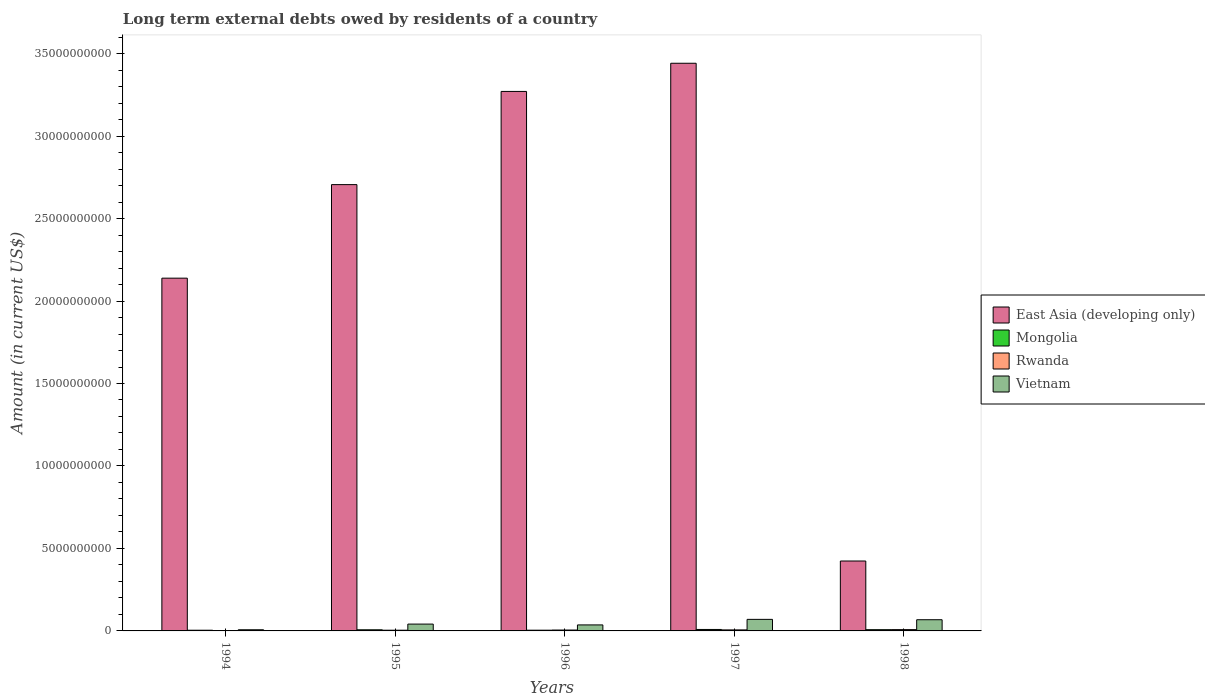Are the number of bars per tick equal to the number of legend labels?
Offer a terse response. Yes. How many bars are there on the 3rd tick from the right?
Your answer should be very brief. 4. In how many cases, is the number of bars for a given year not equal to the number of legend labels?
Offer a very short reply. 0. What is the amount of long-term external debts owed by residents in Vietnam in 1994?
Your response must be concise. 7.06e+07. Across all years, what is the maximum amount of long-term external debts owed by residents in Rwanda?
Your response must be concise. 7.89e+07. Across all years, what is the minimum amount of long-term external debts owed by residents in Vietnam?
Your answer should be compact. 7.06e+07. What is the total amount of long-term external debts owed by residents in East Asia (developing only) in the graph?
Offer a terse response. 1.20e+11. What is the difference between the amount of long-term external debts owed by residents in East Asia (developing only) in 1995 and that in 1997?
Make the answer very short. -7.36e+09. What is the difference between the amount of long-term external debts owed by residents in Mongolia in 1998 and the amount of long-term external debts owed by residents in Rwanda in 1995?
Provide a short and direct response. 3.31e+07. What is the average amount of long-term external debts owed by residents in Mongolia per year?
Offer a terse response. 6.38e+07. In the year 1994, what is the difference between the amount of long-term external debts owed by residents in Vietnam and amount of long-term external debts owed by residents in Rwanda?
Ensure brevity in your answer.  5.03e+07. What is the ratio of the amount of long-term external debts owed by residents in Rwanda in 1994 to that in 1997?
Offer a terse response. 0.33. What is the difference between the highest and the second highest amount of long-term external debts owed by residents in East Asia (developing only)?
Provide a succinct answer. 1.71e+09. What is the difference between the highest and the lowest amount of long-term external debts owed by residents in Vietnam?
Your response must be concise. 6.30e+08. Is it the case that in every year, the sum of the amount of long-term external debts owed by residents in Rwanda and amount of long-term external debts owed by residents in Vietnam is greater than the sum of amount of long-term external debts owed by residents in East Asia (developing only) and amount of long-term external debts owed by residents in Mongolia?
Offer a terse response. No. What does the 4th bar from the left in 1994 represents?
Make the answer very short. Vietnam. What does the 1st bar from the right in 1998 represents?
Keep it short and to the point. Vietnam. Is it the case that in every year, the sum of the amount of long-term external debts owed by residents in East Asia (developing only) and amount of long-term external debts owed by residents in Vietnam is greater than the amount of long-term external debts owed by residents in Rwanda?
Keep it short and to the point. Yes. What is the difference between two consecutive major ticks on the Y-axis?
Your answer should be very brief. 5.00e+09. Where does the legend appear in the graph?
Provide a short and direct response. Center right. What is the title of the graph?
Keep it short and to the point. Long term external debts owed by residents of a country. What is the label or title of the Y-axis?
Keep it short and to the point. Amount (in current US$). What is the Amount (in current US$) in East Asia (developing only) in 1994?
Ensure brevity in your answer.  2.14e+1. What is the Amount (in current US$) in Mongolia in 1994?
Provide a short and direct response. 4.17e+07. What is the Amount (in current US$) in Rwanda in 1994?
Keep it short and to the point. 2.04e+07. What is the Amount (in current US$) of Vietnam in 1994?
Your answer should be compact. 7.06e+07. What is the Amount (in current US$) of East Asia (developing only) in 1995?
Your response must be concise. 2.71e+1. What is the Amount (in current US$) of Mongolia in 1995?
Your response must be concise. 6.84e+07. What is the Amount (in current US$) in Rwanda in 1995?
Give a very brief answer. 4.26e+07. What is the Amount (in current US$) of Vietnam in 1995?
Offer a very short reply. 4.14e+08. What is the Amount (in current US$) of East Asia (developing only) in 1996?
Offer a very short reply. 3.27e+1. What is the Amount (in current US$) of Mongolia in 1996?
Offer a terse response. 4.43e+07. What is the Amount (in current US$) in Rwanda in 1996?
Keep it short and to the point. 5.33e+07. What is the Amount (in current US$) of Vietnam in 1996?
Offer a terse response. 3.64e+08. What is the Amount (in current US$) in East Asia (developing only) in 1997?
Your answer should be compact. 3.44e+1. What is the Amount (in current US$) of Mongolia in 1997?
Your response must be concise. 8.88e+07. What is the Amount (in current US$) in Rwanda in 1997?
Your answer should be compact. 6.18e+07. What is the Amount (in current US$) of Vietnam in 1997?
Make the answer very short. 7.01e+08. What is the Amount (in current US$) of East Asia (developing only) in 1998?
Provide a succinct answer. 4.24e+09. What is the Amount (in current US$) of Mongolia in 1998?
Make the answer very short. 7.57e+07. What is the Amount (in current US$) of Rwanda in 1998?
Keep it short and to the point. 7.89e+07. What is the Amount (in current US$) in Vietnam in 1998?
Offer a very short reply. 6.79e+08. Across all years, what is the maximum Amount (in current US$) in East Asia (developing only)?
Your response must be concise. 3.44e+1. Across all years, what is the maximum Amount (in current US$) of Mongolia?
Keep it short and to the point. 8.88e+07. Across all years, what is the maximum Amount (in current US$) of Rwanda?
Offer a very short reply. 7.89e+07. Across all years, what is the maximum Amount (in current US$) of Vietnam?
Your answer should be compact. 7.01e+08. Across all years, what is the minimum Amount (in current US$) of East Asia (developing only)?
Provide a succinct answer. 4.24e+09. Across all years, what is the minimum Amount (in current US$) of Mongolia?
Ensure brevity in your answer.  4.17e+07. Across all years, what is the minimum Amount (in current US$) in Rwanda?
Your answer should be compact. 2.04e+07. Across all years, what is the minimum Amount (in current US$) in Vietnam?
Give a very brief answer. 7.06e+07. What is the total Amount (in current US$) of East Asia (developing only) in the graph?
Your response must be concise. 1.20e+11. What is the total Amount (in current US$) in Mongolia in the graph?
Your answer should be compact. 3.19e+08. What is the total Amount (in current US$) in Rwanda in the graph?
Offer a very short reply. 2.57e+08. What is the total Amount (in current US$) of Vietnam in the graph?
Make the answer very short. 2.23e+09. What is the difference between the Amount (in current US$) of East Asia (developing only) in 1994 and that in 1995?
Give a very brief answer. -5.67e+09. What is the difference between the Amount (in current US$) of Mongolia in 1994 and that in 1995?
Give a very brief answer. -2.67e+07. What is the difference between the Amount (in current US$) in Rwanda in 1994 and that in 1995?
Offer a terse response. -2.22e+07. What is the difference between the Amount (in current US$) in Vietnam in 1994 and that in 1995?
Your answer should be very brief. -3.43e+08. What is the difference between the Amount (in current US$) of East Asia (developing only) in 1994 and that in 1996?
Your response must be concise. -1.13e+1. What is the difference between the Amount (in current US$) of Mongolia in 1994 and that in 1996?
Your response must be concise. -2.63e+06. What is the difference between the Amount (in current US$) in Rwanda in 1994 and that in 1996?
Your answer should be very brief. -3.29e+07. What is the difference between the Amount (in current US$) of Vietnam in 1994 and that in 1996?
Give a very brief answer. -2.93e+08. What is the difference between the Amount (in current US$) of East Asia (developing only) in 1994 and that in 1997?
Your answer should be very brief. -1.30e+1. What is the difference between the Amount (in current US$) in Mongolia in 1994 and that in 1997?
Your response must be concise. -4.71e+07. What is the difference between the Amount (in current US$) of Rwanda in 1994 and that in 1997?
Your answer should be compact. -4.14e+07. What is the difference between the Amount (in current US$) in Vietnam in 1994 and that in 1997?
Offer a terse response. -6.30e+08. What is the difference between the Amount (in current US$) of East Asia (developing only) in 1994 and that in 1998?
Provide a short and direct response. 1.71e+1. What is the difference between the Amount (in current US$) of Mongolia in 1994 and that in 1998?
Your response must be concise. -3.40e+07. What is the difference between the Amount (in current US$) of Rwanda in 1994 and that in 1998?
Ensure brevity in your answer.  -5.85e+07. What is the difference between the Amount (in current US$) in Vietnam in 1994 and that in 1998?
Make the answer very short. -6.08e+08. What is the difference between the Amount (in current US$) in East Asia (developing only) in 1995 and that in 1996?
Your answer should be very brief. -5.65e+09. What is the difference between the Amount (in current US$) of Mongolia in 1995 and that in 1996?
Your answer should be very brief. 2.41e+07. What is the difference between the Amount (in current US$) of Rwanda in 1995 and that in 1996?
Provide a succinct answer. -1.07e+07. What is the difference between the Amount (in current US$) in Vietnam in 1995 and that in 1996?
Your response must be concise. 5.02e+07. What is the difference between the Amount (in current US$) of East Asia (developing only) in 1995 and that in 1997?
Offer a terse response. -7.36e+09. What is the difference between the Amount (in current US$) of Mongolia in 1995 and that in 1997?
Offer a very short reply. -2.04e+07. What is the difference between the Amount (in current US$) in Rwanda in 1995 and that in 1997?
Ensure brevity in your answer.  -1.92e+07. What is the difference between the Amount (in current US$) of Vietnam in 1995 and that in 1997?
Keep it short and to the point. -2.86e+08. What is the difference between the Amount (in current US$) of East Asia (developing only) in 1995 and that in 1998?
Provide a succinct answer. 2.28e+1. What is the difference between the Amount (in current US$) in Mongolia in 1995 and that in 1998?
Your response must be concise. -7.26e+06. What is the difference between the Amount (in current US$) in Rwanda in 1995 and that in 1998?
Offer a terse response. -3.63e+07. What is the difference between the Amount (in current US$) in Vietnam in 1995 and that in 1998?
Keep it short and to the point. -2.65e+08. What is the difference between the Amount (in current US$) in East Asia (developing only) in 1996 and that in 1997?
Ensure brevity in your answer.  -1.71e+09. What is the difference between the Amount (in current US$) of Mongolia in 1996 and that in 1997?
Your response must be concise. -4.45e+07. What is the difference between the Amount (in current US$) in Rwanda in 1996 and that in 1997?
Provide a succinct answer. -8.49e+06. What is the difference between the Amount (in current US$) in Vietnam in 1996 and that in 1997?
Give a very brief answer. -3.37e+08. What is the difference between the Amount (in current US$) in East Asia (developing only) in 1996 and that in 1998?
Make the answer very short. 2.85e+1. What is the difference between the Amount (in current US$) in Mongolia in 1996 and that in 1998?
Keep it short and to the point. -3.13e+07. What is the difference between the Amount (in current US$) in Rwanda in 1996 and that in 1998?
Provide a short and direct response. -2.56e+07. What is the difference between the Amount (in current US$) in Vietnam in 1996 and that in 1998?
Give a very brief answer. -3.15e+08. What is the difference between the Amount (in current US$) of East Asia (developing only) in 1997 and that in 1998?
Provide a succinct answer. 3.02e+1. What is the difference between the Amount (in current US$) in Mongolia in 1997 and that in 1998?
Provide a short and direct response. 1.32e+07. What is the difference between the Amount (in current US$) in Rwanda in 1997 and that in 1998?
Ensure brevity in your answer.  -1.71e+07. What is the difference between the Amount (in current US$) of Vietnam in 1997 and that in 1998?
Offer a terse response. 2.19e+07. What is the difference between the Amount (in current US$) in East Asia (developing only) in 1994 and the Amount (in current US$) in Mongolia in 1995?
Ensure brevity in your answer.  2.13e+1. What is the difference between the Amount (in current US$) of East Asia (developing only) in 1994 and the Amount (in current US$) of Rwanda in 1995?
Your answer should be compact. 2.13e+1. What is the difference between the Amount (in current US$) of East Asia (developing only) in 1994 and the Amount (in current US$) of Vietnam in 1995?
Keep it short and to the point. 2.10e+1. What is the difference between the Amount (in current US$) in Mongolia in 1994 and the Amount (in current US$) in Rwanda in 1995?
Your response must be concise. -8.97e+05. What is the difference between the Amount (in current US$) of Mongolia in 1994 and the Amount (in current US$) of Vietnam in 1995?
Provide a short and direct response. -3.72e+08. What is the difference between the Amount (in current US$) of Rwanda in 1994 and the Amount (in current US$) of Vietnam in 1995?
Keep it short and to the point. -3.94e+08. What is the difference between the Amount (in current US$) of East Asia (developing only) in 1994 and the Amount (in current US$) of Mongolia in 1996?
Make the answer very short. 2.13e+1. What is the difference between the Amount (in current US$) in East Asia (developing only) in 1994 and the Amount (in current US$) in Rwanda in 1996?
Offer a terse response. 2.13e+1. What is the difference between the Amount (in current US$) in East Asia (developing only) in 1994 and the Amount (in current US$) in Vietnam in 1996?
Your answer should be compact. 2.10e+1. What is the difference between the Amount (in current US$) of Mongolia in 1994 and the Amount (in current US$) of Rwanda in 1996?
Your response must be concise. -1.16e+07. What is the difference between the Amount (in current US$) of Mongolia in 1994 and the Amount (in current US$) of Vietnam in 1996?
Your answer should be very brief. -3.22e+08. What is the difference between the Amount (in current US$) of Rwanda in 1994 and the Amount (in current US$) of Vietnam in 1996?
Offer a very short reply. -3.44e+08. What is the difference between the Amount (in current US$) in East Asia (developing only) in 1994 and the Amount (in current US$) in Mongolia in 1997?
Your answer should be compact. 2.13e+1. What is the difference between the Amount (in current US$) in East Asia (developing only) in 1994 and the Amount (in current US$) in Rwanda in 1997?
Provide a succinct answer. 2.13e+1. What is the difference between the Amount (in current US$) of East Asia (developing only) in 1994 and the Amount (in current US$) of Vietnam in 1997?
Your answer should be compact. 2.07e+1. What is the difference between the Amount (in current US$) in Mongolia in 1994 and the Amount (in current US$) in Rwanda in 1997?
Make the answer very short. -2.01e+07. What is the difference between the Amount (in current US$) in Mongolia in 1994 and the Amount (in current US$) in Vietnam in 1997?
Offer a very short reply. -6.59e+08. What is the difference between the Amount (in current US$) in Rwanda in 1994 and the Amount (in current US$) in Vietnam in 1997?
Provide a succinct answer. -6.80e+08. What is the difference between the Amount (in current US$) in East Asia (developing only) in 1994 and the Amount (in current US$) in Mongolia in 1998?
Offer a terse response. 2.13e+1. What is the difference between the Amount (in current US$) in East Asia (developing only) in 1994 and the Amount (in current US$) in Rwanda in 1998?
Provide a short and direct response. 2.13e+1. What is the difference between the Amount (in current US$) of East Asia (developing only) in 1994 and the Amount (in current US$) of Vietnam in 1998?
Offer a terse response. 2.07e+1. What is the difference between the Amount (in current US$) in Mongolia in 1994 and the Amount (in current US$) in Rwanda in 1998?
Your response must be concise. -3.72e+07. What is the difference between the Amount (in current US$) in Mongolia in 1994 and the Amount (in current US$) in Vietnam in 1998?
Offer a very short reply. -6.37e+08. What is the difference between the Amount (in current US$) in Rwanda in 1994 and the Amount (in current US$) in Vietnam in 1998?
Make the answer very short. -6.58e+08. What is the difference between the Amount (in current US$) in East Asia (developing only) in 1995 and the Amount (in current US$) in Mongolia in 1996?
Offer a very short reply. 2.70e+1. What is the difference between the Amount (in current US$) in East Asia (developing only) in 1995 and the Amount (in current US$) in Rwanda in 1996?
Keep it short and to the point. 2.70e+1. What is the difference between the Amount (in current US$) of East Asia (developing only) in 1995 and the Amount (in current US$) of Vietnam in 1996?
Make the answer very short. 2.67e+1. What is the difference between the Amount (in current US$) of Mongolia in 1995 and the Amount (in current US$) of Rwanda in 1996?
Ensure brevity in your answer.  1.51e+07. What is the difference between the Amount (in current US$) in Mongolia in 1995 and the Amount (in current US$) in Vietnam in 1996?
Your answer should be very brief. -2.96e+08. What is the difference between the Amount (in current US$) of Rwanda in 1995 and the Amount (in current US$) of Vietnam in 1996?
Your answer should be very brief. -3.21e+08. What is the difference between the Amount (in current US$) of East Asia (developing only) in 1995 and the Amount (in current US$) of Mongolia in 1997?
Offer a terse response. 2.70e+1. What is the difference between the Amount (in current US$) of East Asia (developing only) in 1995 and the Amount (in current US$) of Rwanda in 1997?
Make the answer very short. 2.70e+1. What is the difference between the Amount (in current US$) in East Asia (developing only) in 1995 and the Amount (in current US$) in Vietnam in 1997?
Offer a terse response. 2.64e+1. What is the difference between the Amount (in current US$) in Mongolia in 1995 and the Amount (in current US$) in Rwanda in 1997?
Ensure brevity in your answer.  6.60e+06. What is the difference between the Amount (in current US$) in Mongolia in 1995 and the Amount (in current US$) in Vietnam in 1997?
Ensure brevity in your answer.  -6.32e+08. What is the difference between the Amount (in current US$) of Rwanda in 1995 and the Amount (in current US$) of Vietnam in 1997?
Make the answer very short. -6.58e+08. What is the difference between the Amount (in current US$) in East Asia (developing only) in 1995 and the Amount (in current US$) in Mongolia in 1998?
Offer a terse response. 2.70e+1. What is the difference between the Amount (in current US$) in East Asia (developing only) in 1995 and the Amount (in current US$) in Rwanda in 1998?
Ensure brevity in your answer.  2.70e+1. What is the difference between the Amount (in current US$) of East Asia (developing only) in 1995 and the Amount (in current US$) of Vietnam in 1998?
Offer a terse response. 2.64e+1. What is the difference between the Amount (in current US$) in Mongolia in 1995 and the Amount (in current US$) in Rwanda in 1998?
Give a very brief answer. -1.05e+07. What is the difference between the Amount (in current US$) of Mongolia in 1995 and the Amount (in current US$) of Vietnam in 1998?
Provide a succinct answer. -6.10e+08. What is the difference between the Amount (in current US$) of Rwanda in 1995 and the Amount (in current US$) of Vietnam in 1998?
Your response must be concise. -6.36e+08. What is the difference between the Amount (in current US$) in East Asia (developing only) in 1996 and the Amount (in current US$) in Mongolia in 1997?
Offer a terse response. 3.26e+1. What is the difference between the Amount (in current US$) of East Asia (developing only) in 1996 and the Amount (in current US$) of Rwanda in 1997?
Provide a short and direct response. 3.26e+1. What is the difference between the Amount (in current US$) in East Asia (developing only) in 1996 and the Amount (in current US$) in Vietnam in 1997?
Provide a succinct answer. 3.20e+1. What is the difference between the Amount (in current US$) of Mongolia in 1996 and the Amount (in current US$) of Rwanda in 1997?
Offer a terse response. -1.75e+07. What is the difference between the Amount (in current US$) of Mongolia in 1996 and the Amount (in current US$) of Vietnam in 1997?
Your answer should be very brief. -6.56e+08. What is the difference between the Amount (in current US$) in Rwanda in 1996 and the Amount (in current US$) in Vietnam in 1997?
Your answer should be very brief. -6.47e+08. What is the difference between the Amount (in current US$) of East Asia (developing only) in 1996 and the Amount (in current US$) of Mongolia in 1998?
Offer a terse response. 3.26e+1. What is the difference between the Amount (in current US$) in East Asia (developing only) in 1996 and the Amount (in current US$) in Rwanda in 1998?
Make the answer very short. 3.26e+1. What is the difference between the Amount (in current US$) of East Asia (developing only) in 1996 and the Amount (in current US$) of Vietnam in 1998?
Give a very brief answer. 3.20e+1. What is the difference between the Amount (in current US$) of Mongolia in 1996 and the Amount (in current US$) of Rwanda in 1998?
Ensure brevity in your answer.  -3.45e+07. What is the difference between the Amount (in current US$) of Mongolia in 1996 and the Amount (in current US$) of Vietnam in 1998?
Your response must be concise. -6.34e+08. What is the difference between the Amount (in current US$) in Rwanda in 1996 and the Amount (in current US$) in Vietnam in 1998?
Offer a very short reply. -6.25e+08. What is the difference between the Amount (in current US$) of East Asia (developing only) in 1997 and the Amount (in current US$) of Mongolia in 1998?
Ensure brevity in your answer.  3.43e+1. What is the difference between the Amount (in current US$) in East Asia (developing only) in 1997 and the Amount (in current US$) in Rwanda in 1998?
Offer a very short reply. 3.43e+1. What is the difference between the Amount (in current US$) of East Asia (developing only) in 1997 and the Amount (in current US$) of Vietnam in 1998?
Your answer should be compact. 3.37e+1. What is the difference between the Amount (in current US$) of Mongolia in 1997 and the Amount (in current US$) of Rwanda in 1998?
Offer a terse response. 9.96e+06. What is the difference between the Amount (in current US$) of Mongolia in 1997 and the Amount (in current US$) of Vietnam in 1998?
Give a very brief answer. -5.90e+08. What is the difference between the Amount (in current US$) in Rwanda in 1997 and the Amount (in current US$) in Vietnam in 1998?
Provide a short and direct response. -6.17e+08. What is the average Amount (in current US$) of East Asia (developing only) per year?
Your answer should be very brief. 2.40e+1. What is the average Amount (in current US$) of Mongolia per year?
Offer a very short reply. 6.38e+07. What is the average Amount (in current US$) in Rwanda per year?
Your answer should be compact. 5.14e+07. What is the average Amount (in current US$) in Vietnam per year?
Keep it short and to the point. 4.46e+08. In the year 1994, what is the difference between the Amount (in current US$) in East Asia (developing only) and Amount (in current US$) in Mongolia?
Offer a terse response. 2.13e+1. In the year 1994, what is the difference between the Amount (in current US$) in East Asia (developing only) and Amount (in current US$) in Rwanda?
Offer a terse response. 2.14e+1. In the year 1994, what is the difference between the Amount (in current US$) of East Asia (developing only) and Amount (in current US$) of Vietnam?
Offer a very short reply. 2.13e+1. In the year 1994, what is the difference between the Amount (in current US$) of Mongolia and Amount (in current US$) of Rwanda?
Your response must be concise. 2.13e+07. In the year 1994, what is the difference between the Amount (in current US$) in Mongolia and Amount (in current US$) in Vietnam?
Provide a short and direct response. -2.89e+07. In the year 1994, what is the difference between the Amount (in current US$) of Rwanda and Amount (in current US$) of Vietnam?
Offer a terse response. -5.03e+07. In the year 1995, what is the difference between the Amount (in current US$) in East Asia (developing only) and Amount (in current US$) in Mongolia?
Make the answer very short. 2.70e+1. In the year 1995, what is the difference between the Amount (in current US$) of East Asia (developing only) and Amount (in current US$) of Rwanda?
Your response must be concise. 2.70e+1. In the year 1995, what is the difference between the Amount (in current US$) of East Asia (developing only) and Amount (in current US$) of Vietnam?
Offer a terse response. 2.66e+1. In the year 1995, what is the difference between the Amount (in current US$) of Mongolia and Amount (in current US$) of Rwanda?
Provide a short and direct response. 2.58e+07. In the year 1995, what is the difference between the Amount (in current US$) of Mongolia and Amount (in current US$) of Vietnam?
Give a very brief answer. -3.46e+08. In the year 1995, what is the difference between the Amount (in current US$) in Rwanda and Amount (in current US$) in Vietnam?
Your response must be concise. -3.72e+08. In the year 1996, what is the difference between the Amount (in current US$) in East Asia (developing only) and Amount (in current US$) in Mongolia?
Your answer should be very brief. 3.27e+1. In the year 1996, what is the difference between the Amount (in current US$) of East Asia (developing only) and Amount (in current US$) of Rwanda?
Your response must be concise. 3.27e+1. In the year 1996, what is the difference between the Amount (in current US$) of East Asia (developing only) and Amount (in current US$) of Vietnam?
Make the answer very short. 3.23e+1. In the year 1996, what is the difference between the Amount (in current US$) of Mongolia and Amount (in current US$) of Rwanda?
Keep it short and to the point. -8.96e+06. In the year 1996, what is the difference between the Amount (in current US$) of Mongolia and Amount (in current US$) of Vietnam?
Offer a terse response. -3.20e+08. In the year 1996, what is the difference between the Amount (in current US$) in Rwanda and Amount (in current US$) in Vietnam?
Your answer should be compact. -3.11e+08. In the year 1997, what is the difference between the Amount (in current US$) of East Asia (developing only) and Amount (in current US$) of Mongolia?
Ensure brevity in your answer.  3.43e+1. In the year 1997, what is the difference between the Amount (in current US$) of East Asia (developing only) and Amount (in current US$) of Rwanda?
Offer a very short reply. 3.44e+1. In the year 1997, what is the difference between the Amount (in current US$) of East Asia (developing only) and Amount (in current US$) of Vietnam?
Your answer should be compact. 3.37e+1. In the year 1997, what is the difference between the Amount (in current US$) in Mongolia and Amount (in current US$) in Rwanda?
Ensure brevity in your answer.  2.70e+07. In the year 1997, what is the difference between the Amount (in current US$) of Mongolia and Amount (in current US$) of Vietnam?
Offer a terse response. -6.12e+08. In the year 1997, what is the difference between the Amount (in current US$) of Rwanda and Amount (in current US$) of Vietnam?
Keep it short and to the point. -6.39e+08. In the year 1998, what is the difference between the Amount (in current US$) in East Asia (developing only) and Amount (in current US$) in Mongolia?
Give a very brief answer. 4.16e+09. In the year 1998, what is the difference between the Amount (in current US$) in East Asia (developing only) and Amount (in current US$) in Rwanda?
Ensure brevity in your answer.  4.16e+09. In the year 1998, what is the difference between the Amount (in current US$) of East Asia (developing only) and Amount (in current US$) of Vietnam?
Offer a terse response. 3.56e+09. In the year 1998, what is the difference between the Amount (in current US$) in Mongolia and Amount (in current US$) in Rwanda?
Keep it short and to the point. -3.20e+06. In the year 1998, what is the difference between the Amount (in current US$) in Mongolia and Amount (in current US$) in Vietnam?
Provide a short and direct response. -6.03e+08. In the year 1998, what is the difference between the Amount (in current US$) in Rwanda and Amount (in current US$) in Vietnam?
Give a very brief answer. -6.00e+08. What is the ratio of the Amount (in current US$) of East Asia (developing only) in 1994 to that in 1995?
Your answer should be compact. 0.79. What is the ratio of the Amount (in current US$) in Mongolia in 1994 to that in 1995?
Offer a terse response. 0.61. What is the ratio of the Amount (in current US$) of Rwanda in 1994 to that in 1995?
Offer a terse response. 0.48. What is the ratio of the Amount (in current US$) in Vietnam in 1994 to that in 1995?
Provide a short and direct response. 0.17. What is the ratio of the Amount (in current US$) of East Asia (developing only) in 1994 to that in 1996?
Provide a short and direct response. 0.65. What is the ratio of the Amount (in current US$) of Mongolia in 1994 to that in 1996?
Keep it short and to the point. 0.94. What is the ratio of the Amount (in current US$) in Rwanda in 1994 to that in 1996?
Provide a short and direct response. 0.38. What is the ratio of the Amount (in current US$) in Vietnam in 1994 to that in 1996?
Make the answer very short. 0.19. What is the ratio of the Amount (in current US$) of East Asia (developing only) in 1994 to that in 1997?
Offer a very short reply. 0.62. What is the ratio of the Amount (in current US$) of Mongolia in 1994 to that in 1997?
Provide a short and direct response. 0.47. What is the ratio of the Amount (in current US$) of Rwanda in 1994 to that in 1997?
Your answer should be very brief. 0.33. What is the ratio of the Amount (in current US$) of Vietnam in 1994 to that in 1997?
Offer a terse response. 0.1. What is the ratio of the Amount (in current US$) in East Asia (developing only) in 1994 to that in 1998?
Provide a succinct answer. 5.05. What is the ratio of the Amount (in current US$) of Mongolia in 1994 to that in 1998?
Make the answer very short. 0.55. What is the ratio of the Amount (in current US$) in Rwanda in 1994 to that in 1998?
Offer a terse response. 0.26. What is the ratio of the Amount (in current US$) in Vietnam in 1994 to that in 1998?
Provide a succinct answer. 0.1. What is the ratio of the Amount (in current US$) in East Asia (developing only) in 1995 to that in 1996?
Offer a terse response. 0.83. What is the ratio of the Amount (in current US$) of Mongolia in 1995 to that in 1996?
Keep it short and to the point. 1.54. What is the ratio of the Amount (in current US$) in Rwanda in 1995 to that in 1996?
Your answer should be very brief. 0.8. What is the ratio of the Amount (in current US$) in Vietnam in 1995 to that in 1996?
Provide a short and direct response. 1.14. What is the ratio of the Amount (in current US$) of East Asia (developing only) in 1995 to that in 1997?
Offer a very short reply. 0.79. What is the ratio of the Amount (in current US$) of Mongolia in 1995 to that in 1997?
Provide a short and direct response. 0.77. What is the ratio of the Amount (in current US$) of Rwanda in 1995 to that in 1997?
Your answer should be compact. 0.69. What is the ratio of the Amount (in current US$) in Vietnam in 1995 to that in 1997?
Your answer should be very brief. 0.59. What is the ratio of the Amount (in current US$) of East Asia (developing only) in 1995 to that in 1998?
Offer a very short reply. 6.38. What is the ratio of the Amount (in current US$) of Mongolia in 1995 to that in 1998?
Give a very brief answer. 0.9. What is the ratio of the Amount (in current US$) of Rwanda in 1995 to that in 1998?
Your answer should be very brief. 0.54. What is the ratio of the Amount (in current US$) of Vietnam in 1995 to that in 1998?
Keep it short and to the point. 0.61. What is the ratio of the Amount (in current US$) in East Asia (developing only) in 1996 to that in 1997?
Give a very brief answer. 0.95. What is the ratio of the Amount (in current US$) in Mongolia in 1996 to that in 1997?
Give a very brief answer. 0.5. What is the ratio of the Amount (in current US$) of Rwanda in 1996 to that in 1997?
Ensure brevity in your answer.  0.86. What is the ratio of the Amount (in current US$) of Vietnam in 1996 to that in 1997?
Your answer should be compact. 0.52. What is the ratio of the Amount (in current US$) of East Asia (developing only) in 1996 to that in 1998?
Keep it short and to the point. 7.72. What is the ratio of the Amount (in current US$) in Mongolia in 1996 to that in 1998?
Your answer should be compact. 0.59. What is the ratio of the Amount (in current US$) in Rwanda in 1996 to that in 1998?
Ensure brevity in your answer.  0.68. What is the ratio of the Amount (in current US$) of Vietnam in 1996 to that in 1998?
Your response must be concise. 0.54. What is the ratio of the Amount (in current US$) of East Asia (developing only) in 1997 to that in 1998?
Your answer should be very brief. 8.12. What is the ratio of the Amount (in current US$) in Mongolia in 1997 to that in 1998?
Your answer should be very brief. 1.17. What is the ratio of the Amount (in current US$) in Rwanda in 1997 to that in 1998?
Offer a very short reply. 0.78. What is the ratio of the Amount (in current US$) of Vietnam in 1997 to that in 1998?
Your answer should be compact. 1.03. What is the difference between the highest and the second highest Amount (in current US$) in East Asia (developing only)?
Ensure brevity in your answer.  1.71e+09. What is the difference between the highest and the second highest Amount (in current US$) in Mongolia?
Offer a terse response. 1.32e+07. What is the difference between the highest and the second highest Amount (in current US$) in Rwanda?
Your answer should be compact. 1.71e+07. What is the difference between the highest and the second highest Amount (in current US$) of Vietnam?
Your answer should be very brief. 2.19e+07. What is the difference between the highest and the lowest Amount (in current US$) in East Asia (developing only)?
Provide a short and direct response. 3.02e+1. What is the difference between the highest and the lowest Amount (in current US$) of Mongolia?
Your answer should be compact. 4.71e+07. What is the difference between the highest and the lowest Amount (in current US$) of Rwanda?
Offer a terse response. 5.85e+07. What is the difference between the highest and the lowest Amount (in current US$) in Vietnam?
Provide a short and direct response. 6.30e+08. 